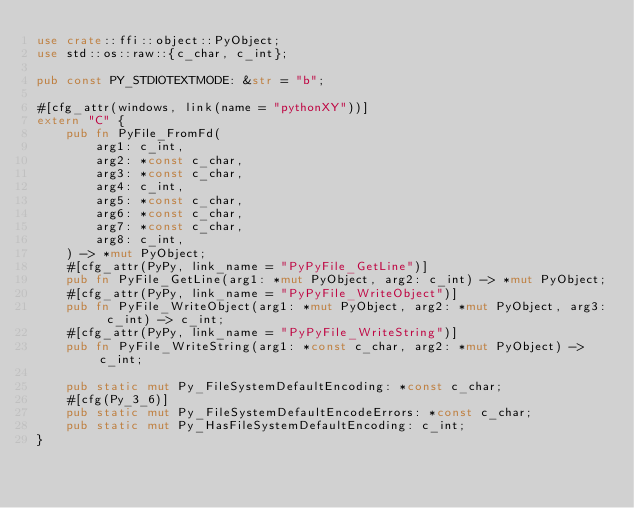Convert code to text. <code><loc_0><loc_0><loc_500><loc_500><_Rust_>use crate::ffi::object::PyObject;
use std::os::raw::{c_char, c_int};

pub const PY_STDIOTEXTMODE: &str = "b";

#[cfg_attr(windows, link(name = "pythonXY"))]
extern "C" {
    pub fn PyFile_FromFd(
        arg1: c_int,
        arg2: *const c_char,
        arg3: *const c_char,
        arg4: c_int,
        arg5: *const c_char,
        arg6: *const c_char,
        arg7: *const c_char,
        arg8: c_int,
    ) -> *mut PyObject;
    #[cfg_attr(PyPy, link_name = "PyPyFile_GetLine")]
    pub fn PyFile_GetLine(arg1: *mut PyObject, arg2: c_int) -> *mut PyObject;
    #[cfg_attr(PyPy, link_name = "PyPyFile_WriteObject")]
    pub fn PyFile_WriteObject(arg1: *mut PyObject, arg2: *mut PyObject, arg3: c_int) -> c_int;
    #[cfg_attr(PyPy, link_name = "PyPyFile_WriteString")]
    pub fn PyFile_WriteString(arg1: *const c_char, arg2: *mut PyObject) -> c_int;

    pub static mut Py_FileSystemDefaultEncoding: *const c_char;
    #[cfg(Py_3_6)]
    pub static mut Py_FileSystemDefaultEncodeErrors: *const c_char;
    pub static mut Py_HasFileSystemDefaultEncoding: c_int;
}
</code> 